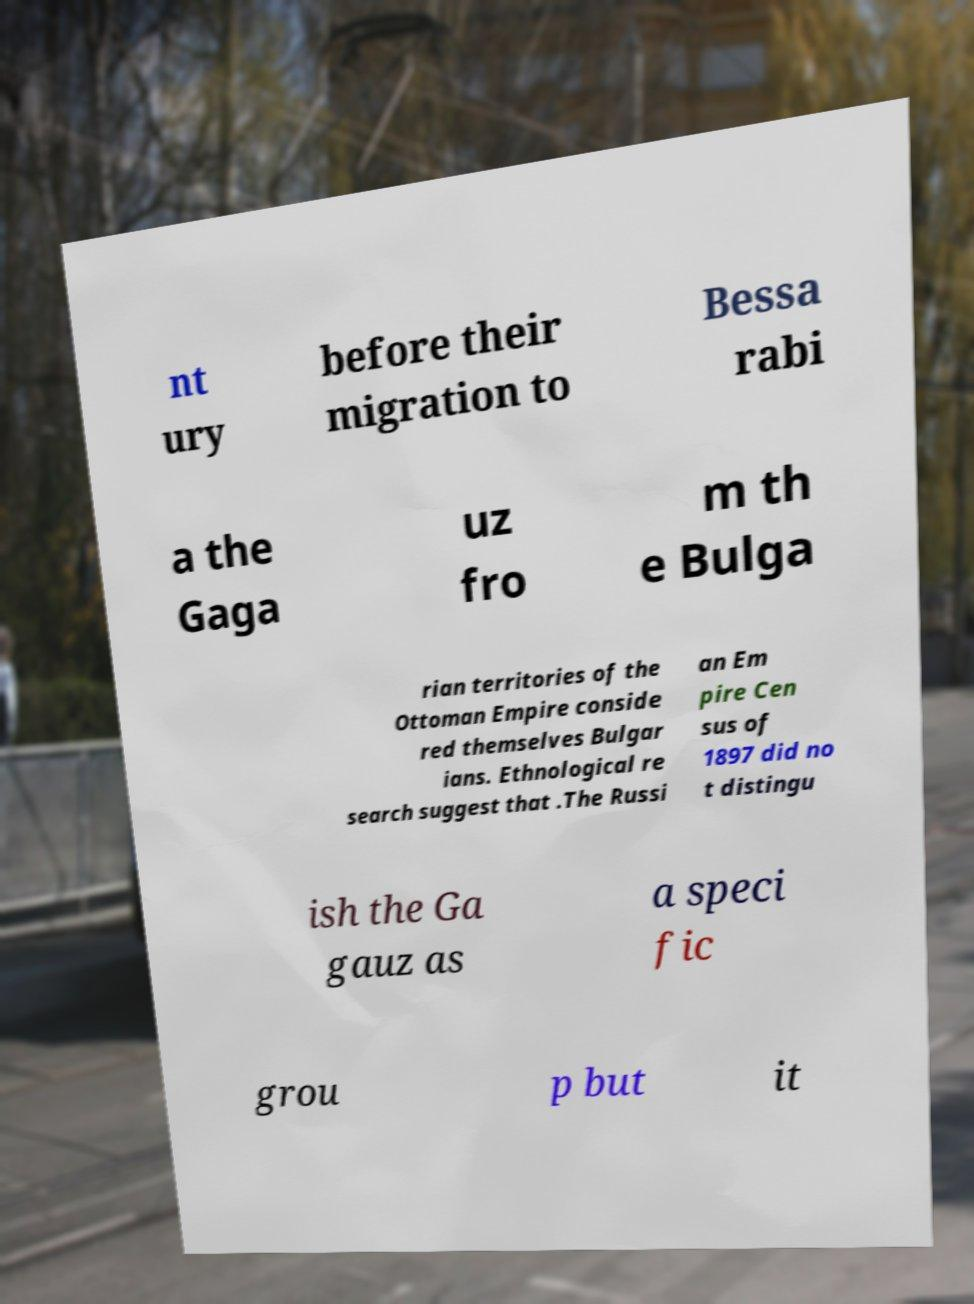What messages or text are displayed in this image? I need them in a readable, typed format. nt ury before their migration to Bessa rabi a the Gaga uz fro m th e Bulga rian territories of the Ottoman Empire conside red themselves Bulgar ians. Ethnological re search suggest that .The Russi an Em pire Cen sus of 1897 did no t distingu ish the Ga gauz as a speci fic grou p but it 